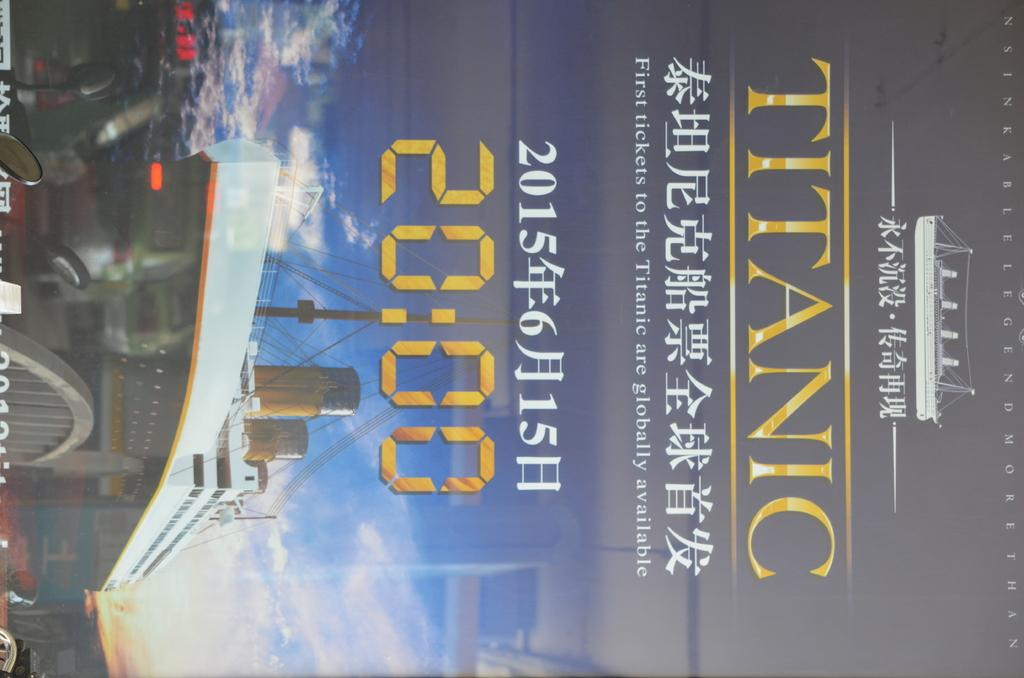<image>
Summarize the visual content of the image. An Advertisement for tickets to Titanic is written in an asian language. 